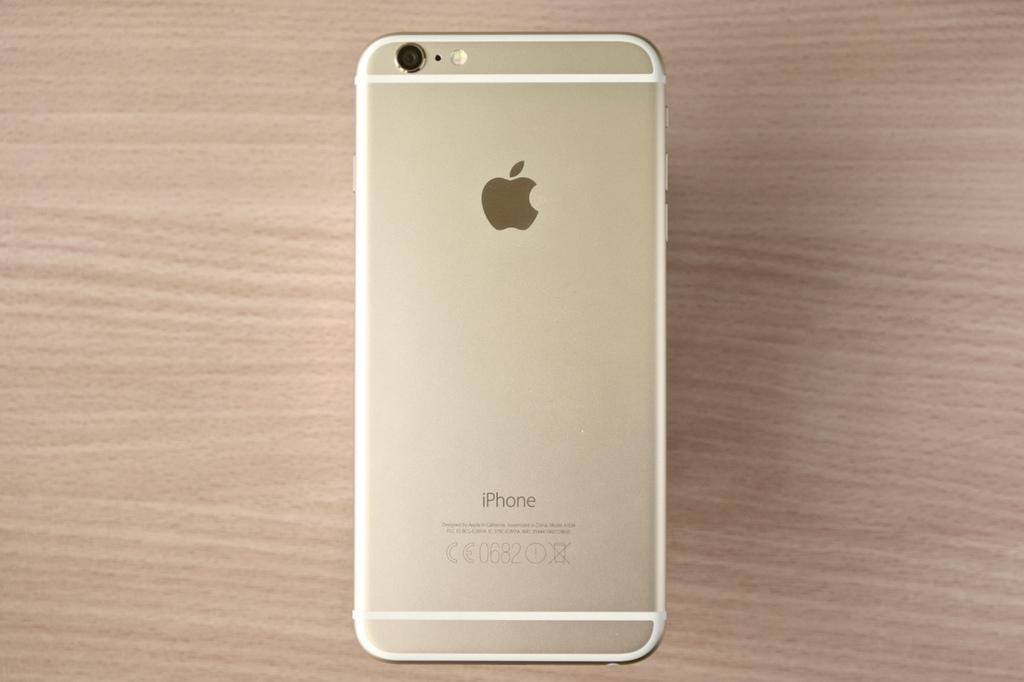<image>
Give a short and clear explanation of the subsequent image. An iPhone is laying face down on a wooden surface. 